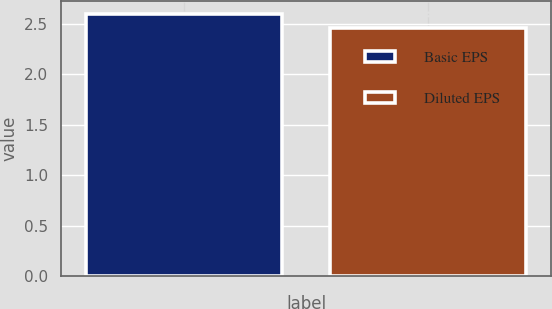<chart> <loc_0><loc_0><loc_500><loc_500><bar_chart><fcel>Basic EPS<fcel>Diluted EPS<nl><fcel>2.6<fcel>2.46<nl></chart> 